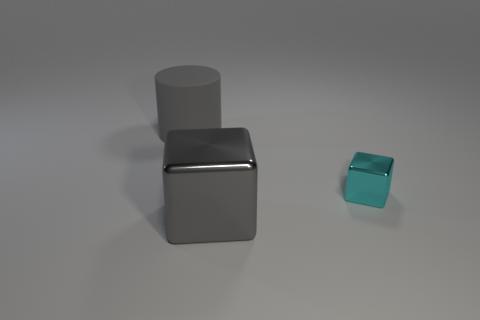Add 1 small brown metallic balls. How many objects exist? 4 Subtract all cylinders. How many objects are left? 2 Subtract all gray blocks. Subtract all metal cubes. How many objects are left? 0 Add 3 cyan metallic blocks. How many cyan metallic blocks are left? 4 Add 3 small cyan metallic cubes. How many small cyan metallic cubes exist? 4 Subtract 0 green cylinders. How many objects are left? 3 